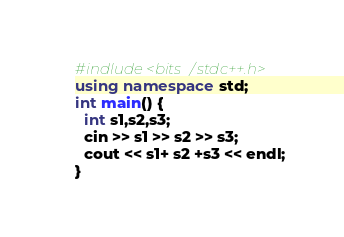<code> <loc_0><loc_0><loc_500><loc_500><_C++_>#indlude <bits/stdc++.h>
using namespace std;
int main() {
  int s1,s2,s3;
  cin >> s1 >> s2 >> s3;
  cout << s1+ s2 +s3 << endl;
}</code> 